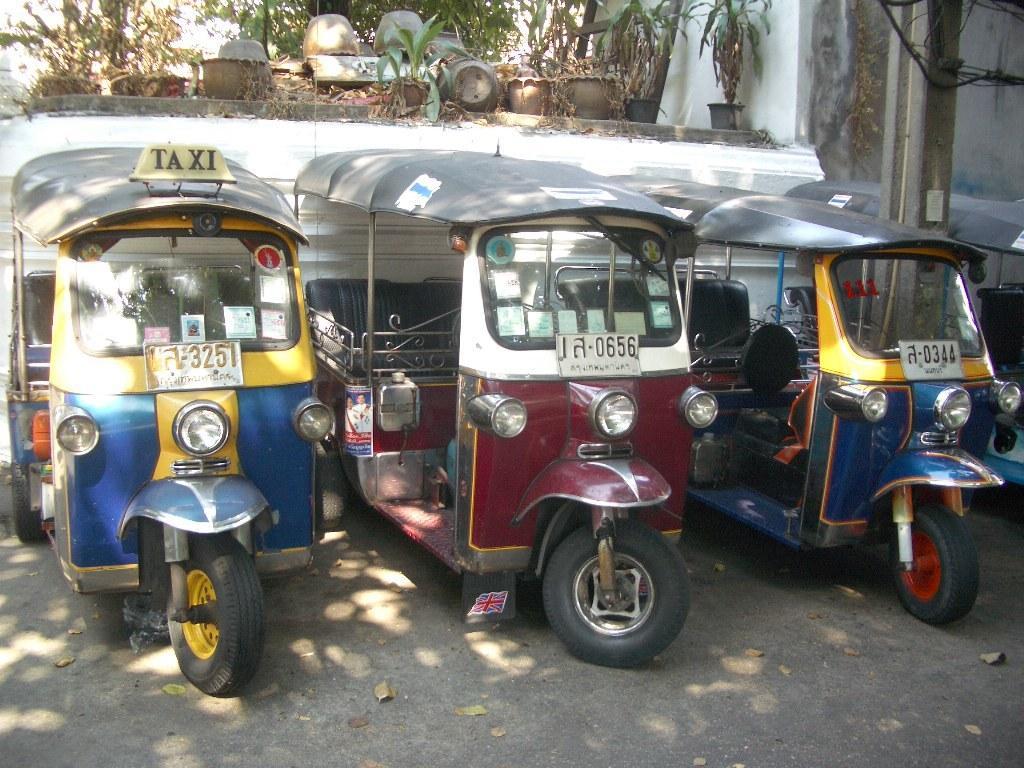In one or two sentences, can you explain what this image depicts? In this picture, we can see a few vehicles on the road, we can see the wall with some objects attached to it, we can see some plants in pots. 